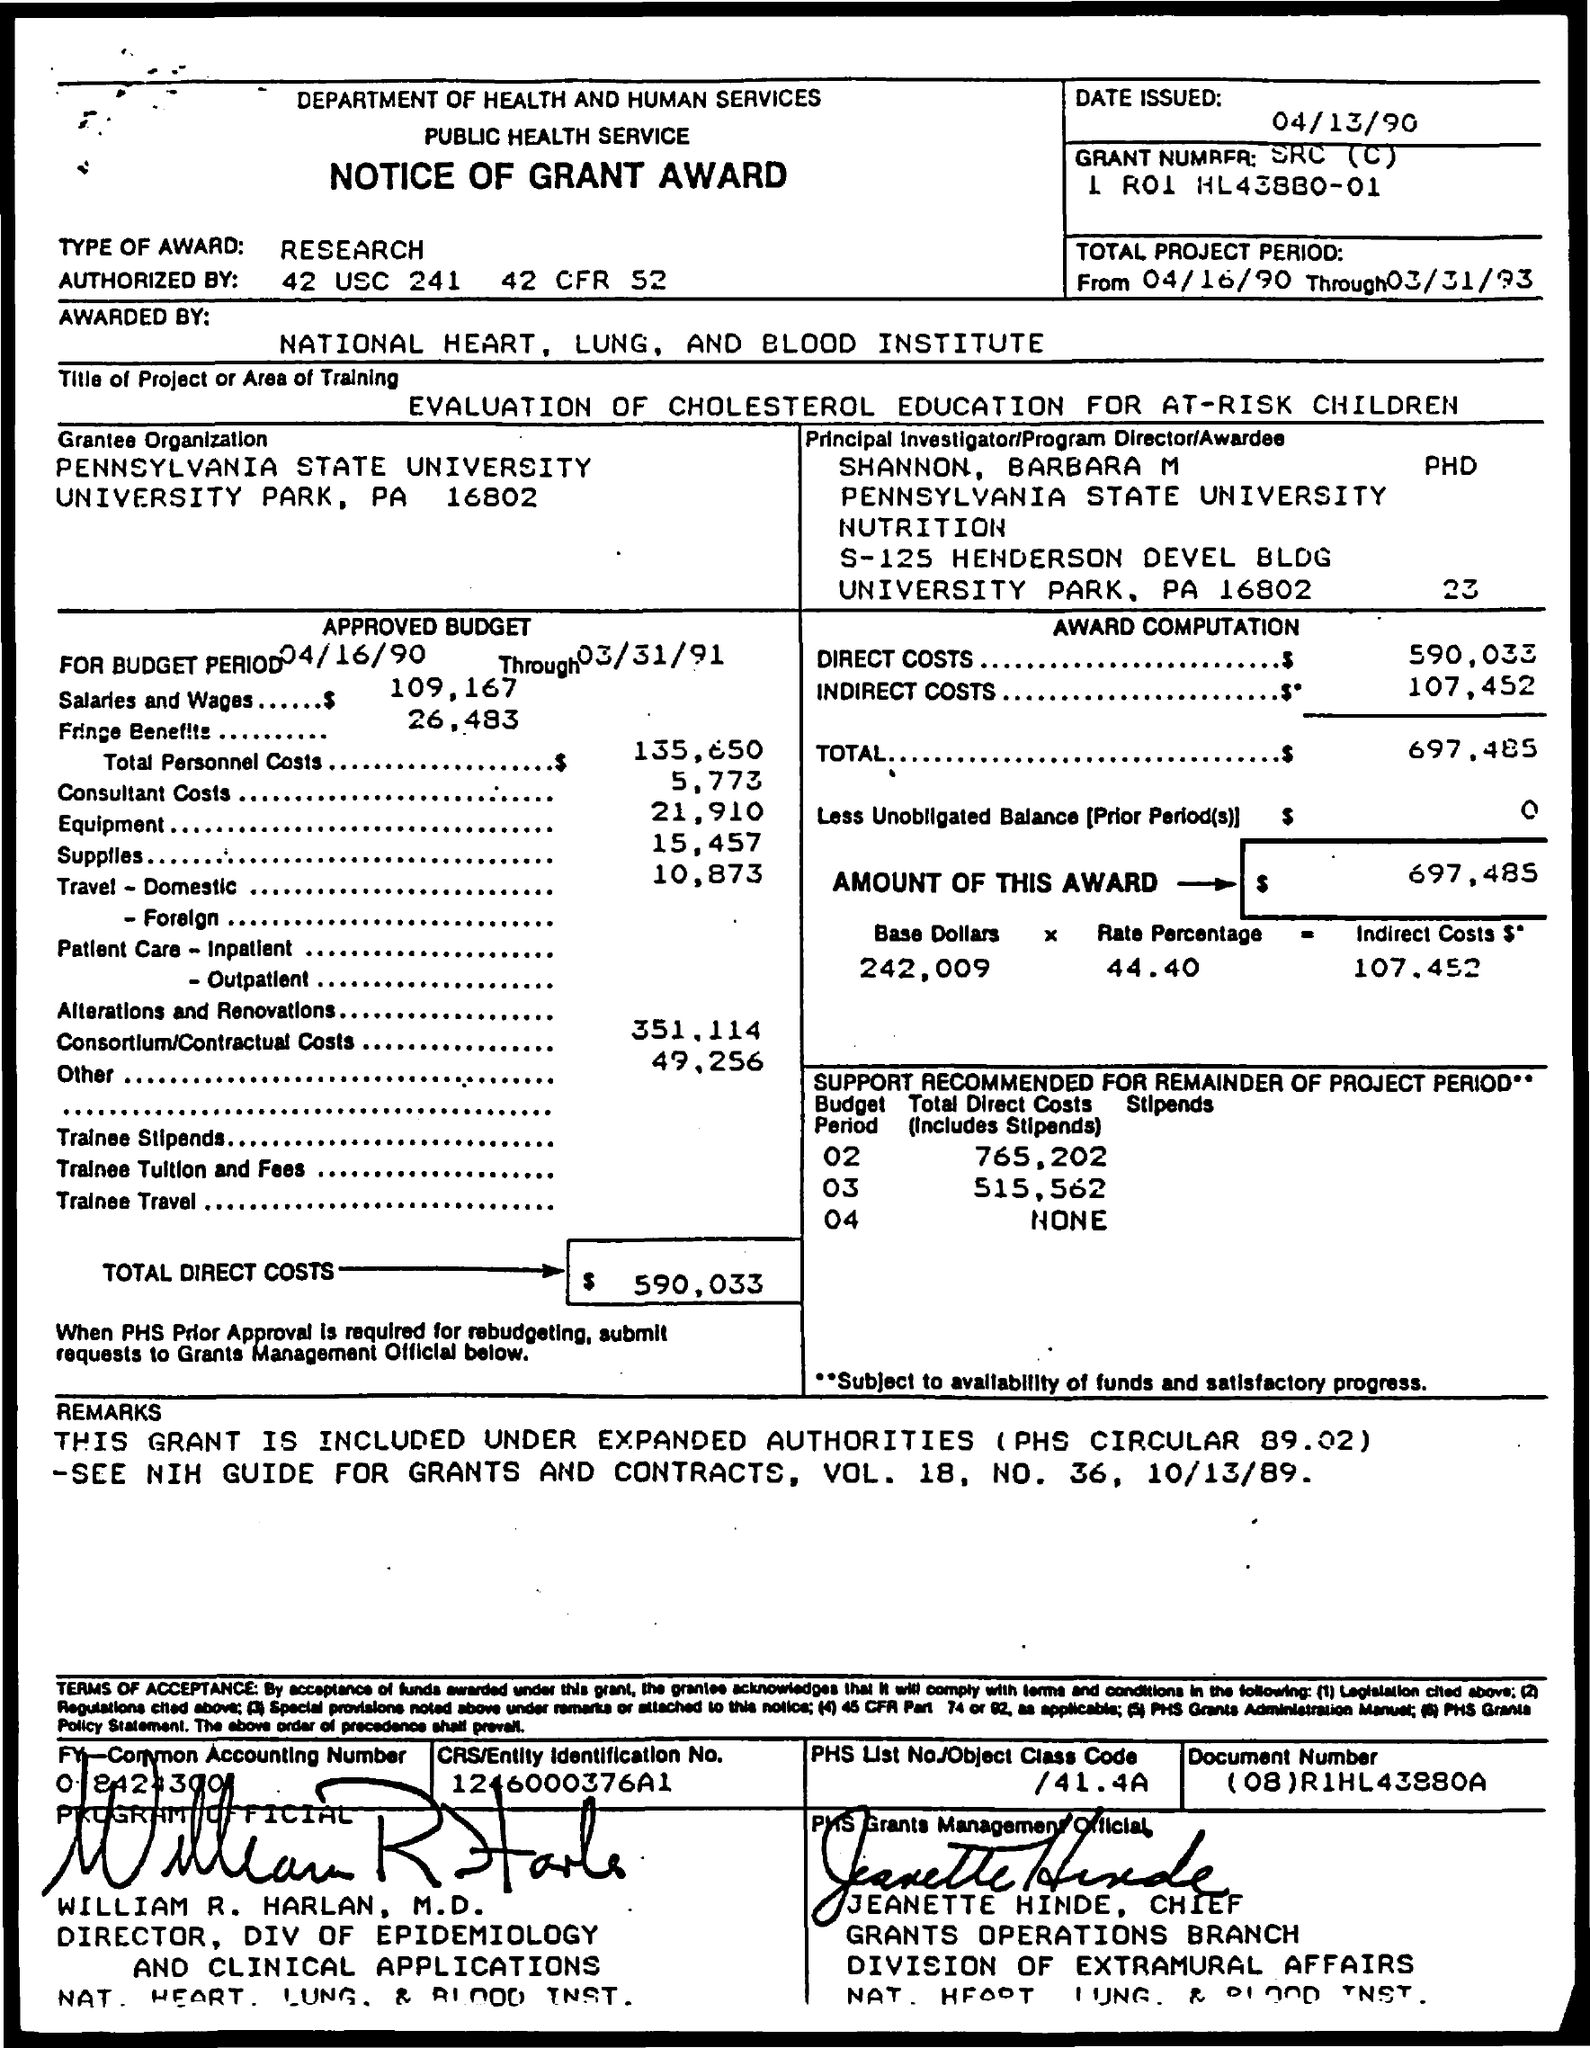What is the main focus of the project funded by this grant? The main focus of the project, as stated in the grant award document, is the 'Evaluation of Cholesterol Education for At-Risk Children.' It is likely to be a public health initiative aimed at improving the health outcomes of children at risk for high cholesterol.  Over what period is the grant expected to be utilized? The grant is allocated to be used over a period from April 16, 1990, to March 31, 1993, according to the grant document. 